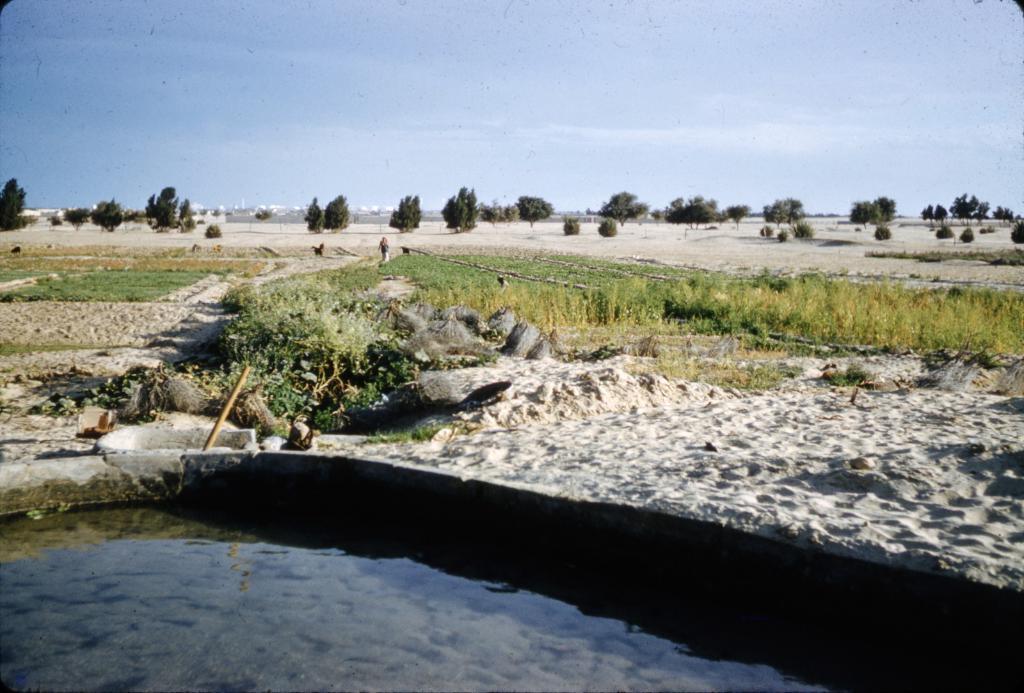How would you summarize this image in a sentence or two? In this picture there is water at the bottom side of the image and there are trees and grassland in the image, there is sky at the top side of the image. 